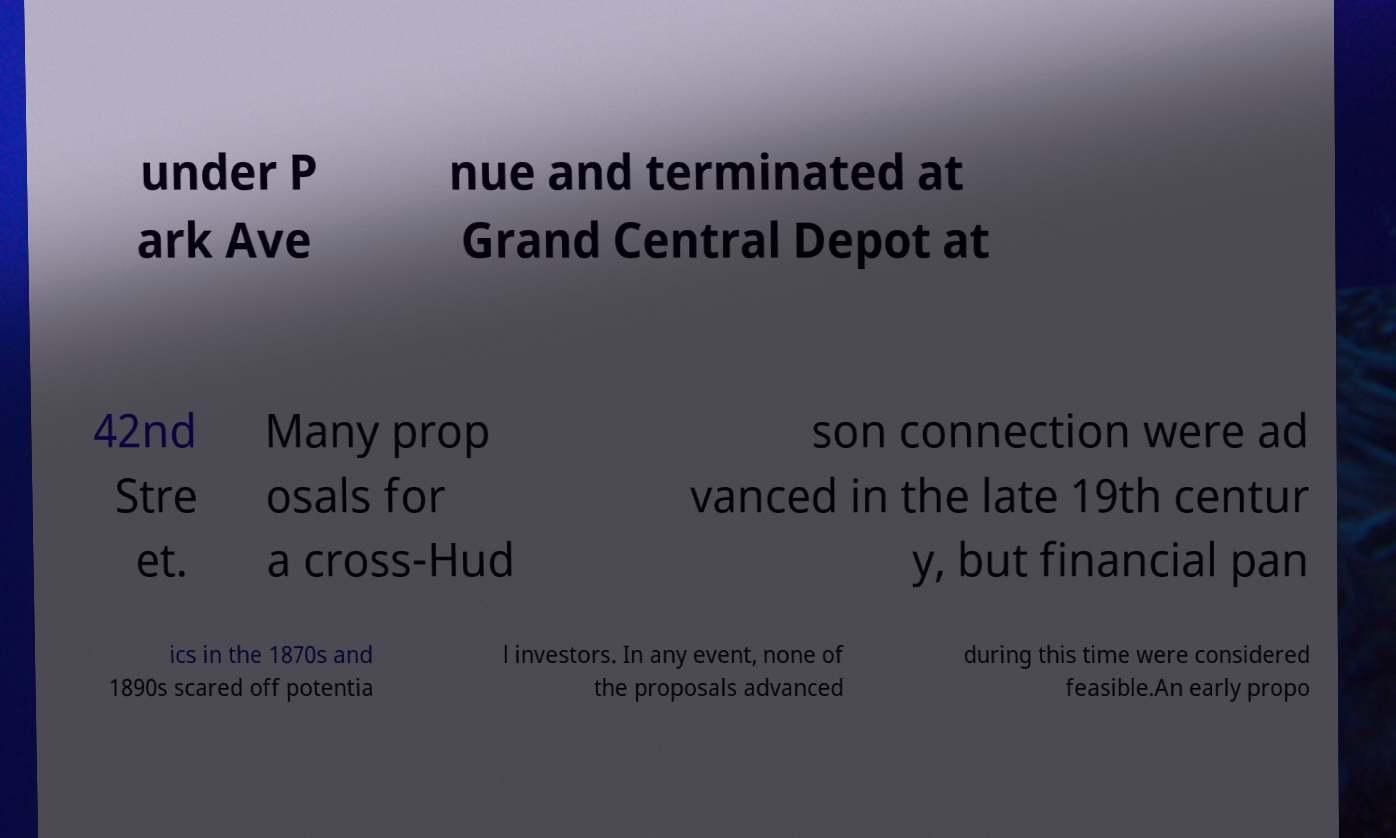Could you assist in decoding the text presented in this image and type it out clearly? under P ark Ave nue and terminated at Grand Central Depot at 42nd Stre et. Many prop osals for a cross-Hud son connection were ad vanced in the late 19th centur y, but financial pan ics in the 1870s and 1890s scared off potentia l investors. In any event, none of the proposals advanced during this time were considered feasible.An early propo 